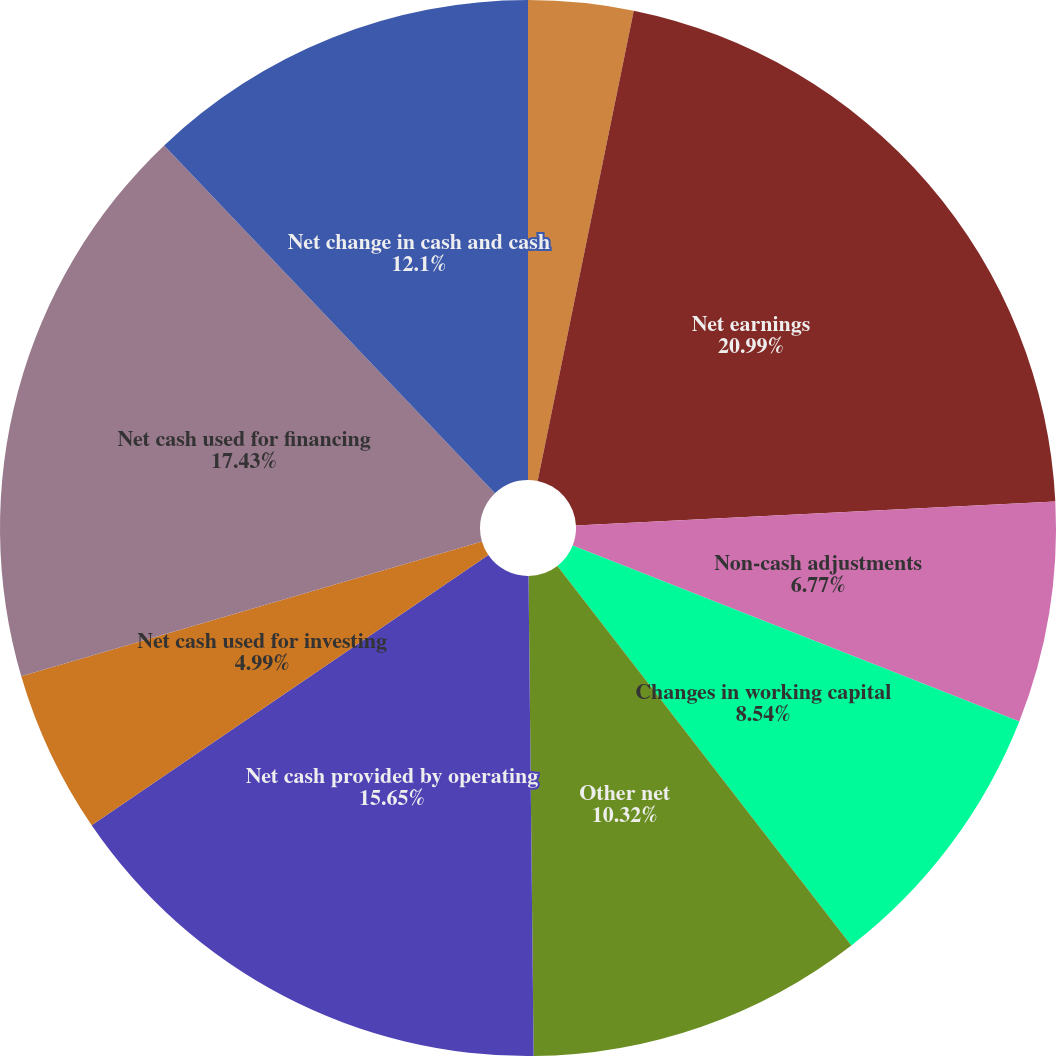Convert chart. <chart><loc_0><loc_0><loc_500><loc_500><pie_chart><fcel>Cash and cash equivalents at<fcel>Net earnings<fcel>Non-cash adjustments<fcel>Changes in working capital<fcel>Other net<fcel>Net cash provided by operating<fcel>Net cash used for investing<fcel>Net cash used for financing<fcel>Net change in cash and cash<nl><fcel>3.21%<fcel>20.99%<fcel>6.77%<fcel>8.54%<fcel>10.32%<fcel>15.65%<fcel>4.99%<fcel>17.43%<fcel>12.1%<nl></chart> 